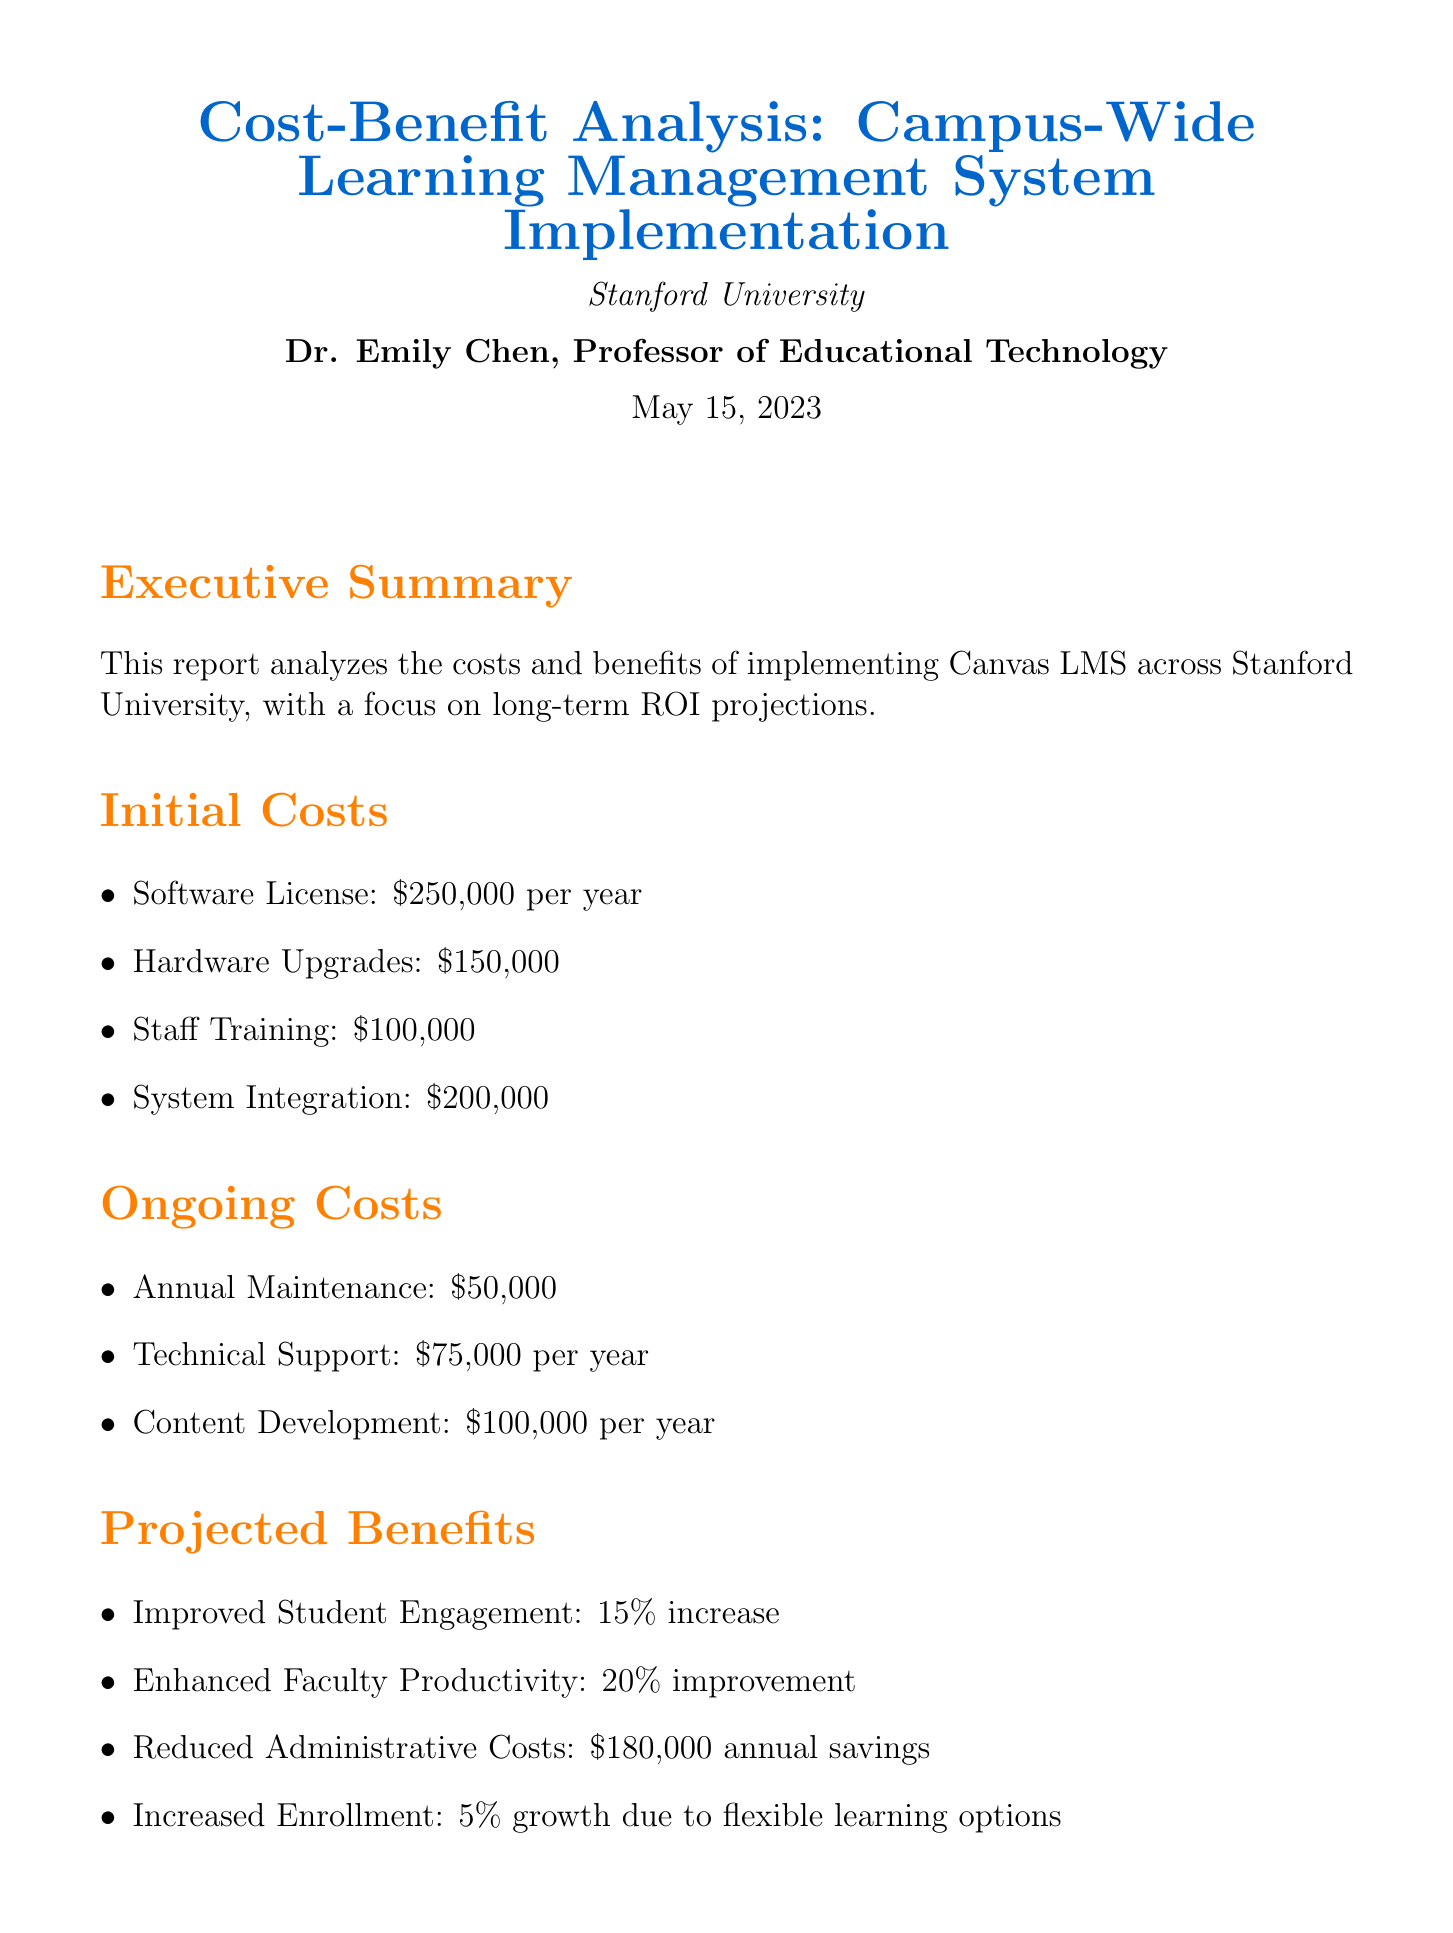What is the total initial cost of the implementation? The total initial cost is the sum of software license, hardware upgrades, staff training, and system integration, which is $250,000 + $150,000 + $100,000 + $200,000 = $700,000.
Answer: $700,000 What is the projected reduction in administrative costs? The projected reduction in administrative costs is specified in the projected benefits section of the document as an annual savings.
Answer: $180,000 Who is the author of the report? The report lists Dr. Emily Chen as the author, outlining her position as a Professor of Educational Technology.
Answer: Dr. Emily Chen What is the projected ROI after 10 years? The long-term ROI projections indicate the estimated return on investment after a decade, as presented in the document.
Answer: 275% What is the expected increase in student engagement? The document highlights a specific percentage increase in student engagement as a key benefit of the LMS implementation.
Answer: 15% increase What is the date of the report? The document includes a date of publication, giving context for when the analysis was conducted.
Answer: May 15, 2023 What type of learning management system is being analyzed? The document specifies the particular learning management system being examined for implementation across Stanford University.
Answer: Canvas LMS What is the annual cost for technical support? The ongoing costs section specifies a yearly cost associated with technical support, detailing its contribution to overall expenses.
Answer: $75,000 per year 